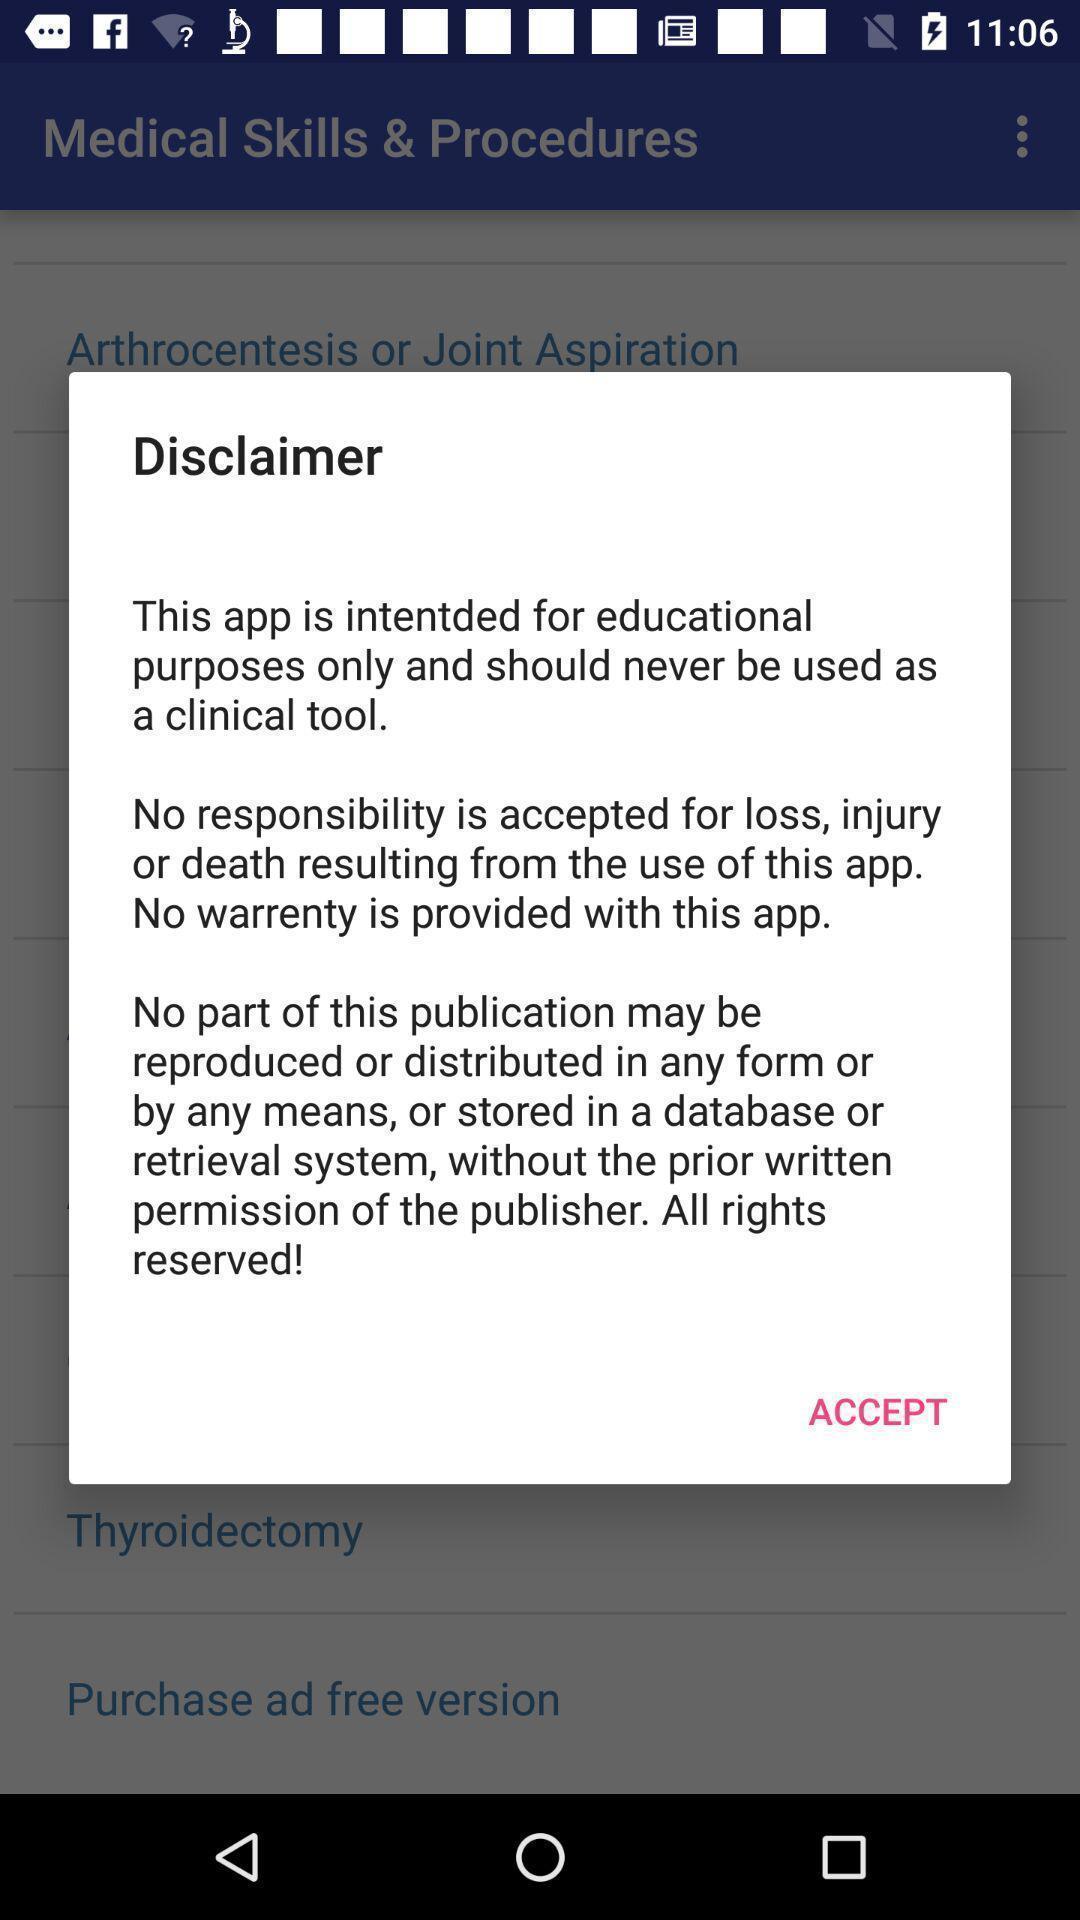Describe this image in words. Pop up displayed disclaimer to accept. 